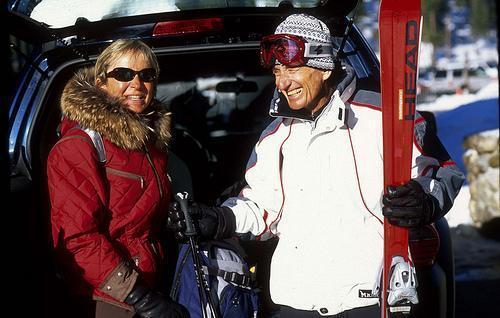How many people are there?
Give a very brief answer. 2. 